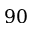Convert formula to latex. <formula><loc_0><loc_0><loc_500><loc_500>9 0</formula> 